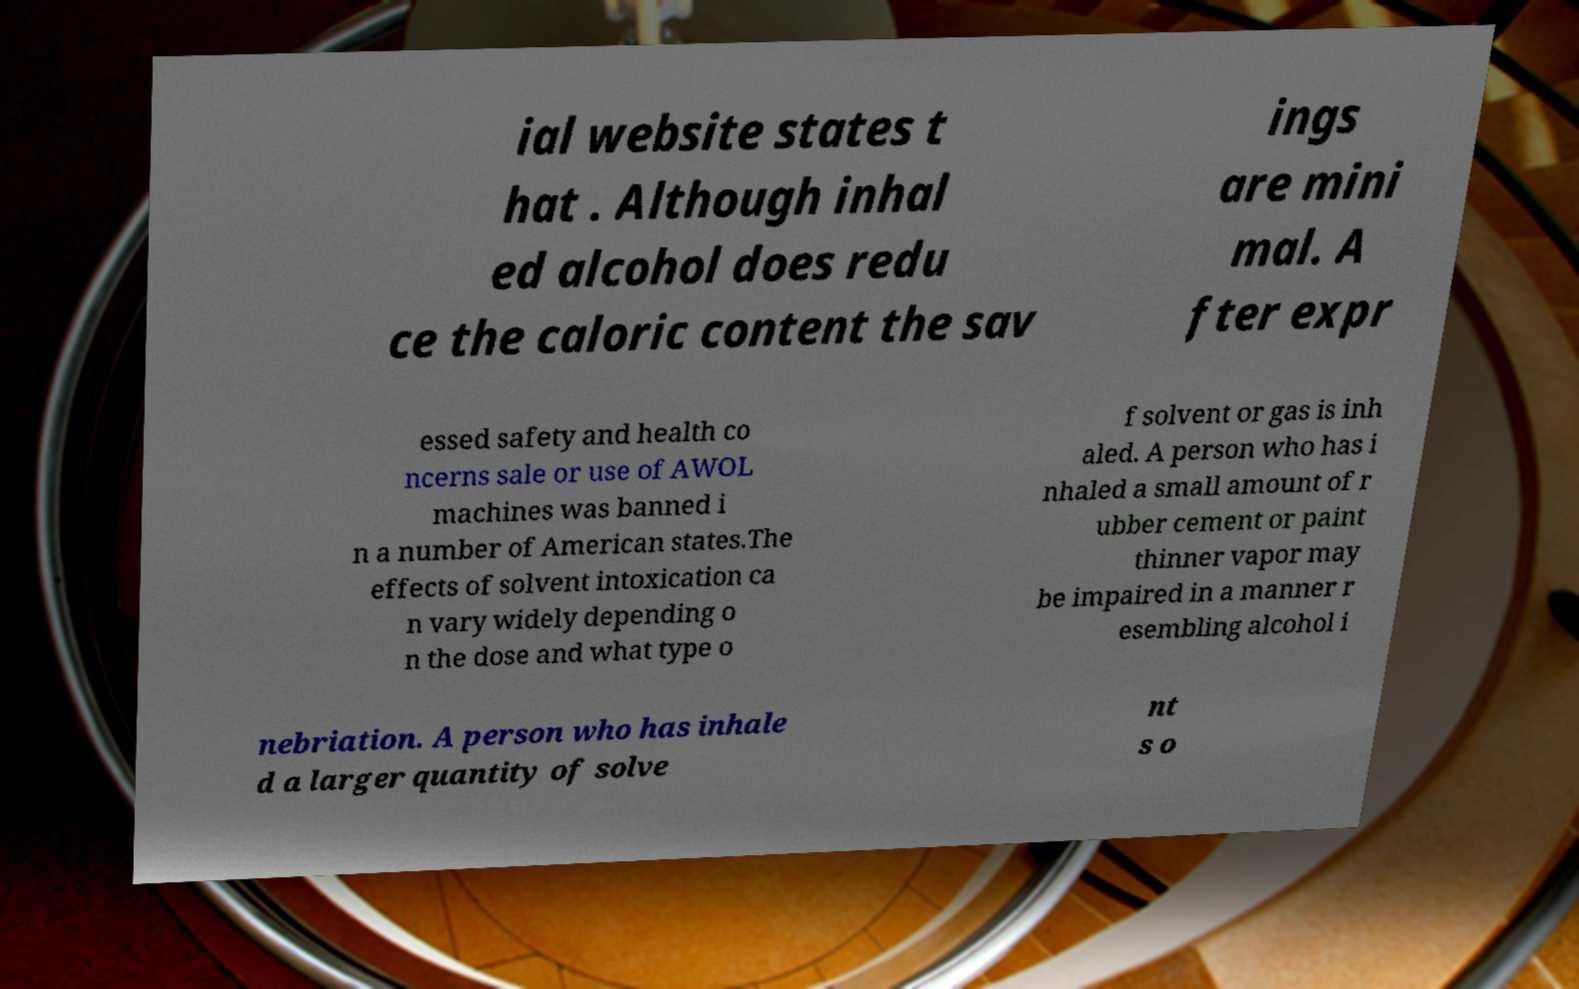There's text embedded in this image that I need extracted. Can you transcribe it verbatim? ial website states t hat . Although inhal ed alcohol does redu ce the caloric content the sav ings are mini mal. A fter expr essed safety and health co ncerns sale or use of AWOL machines was banned i n a number of American states.The effects of solvent intoxication ca n vary widely depending o n the dose and what type o f solvent or gas is inh aled. A person who has i nhaled a small amount of r ubber cement or paint thinner vapor may be impaired in a manner r esembling alcohol i nebriation. A person who has inhale d a larger quantity of solve nt s o 